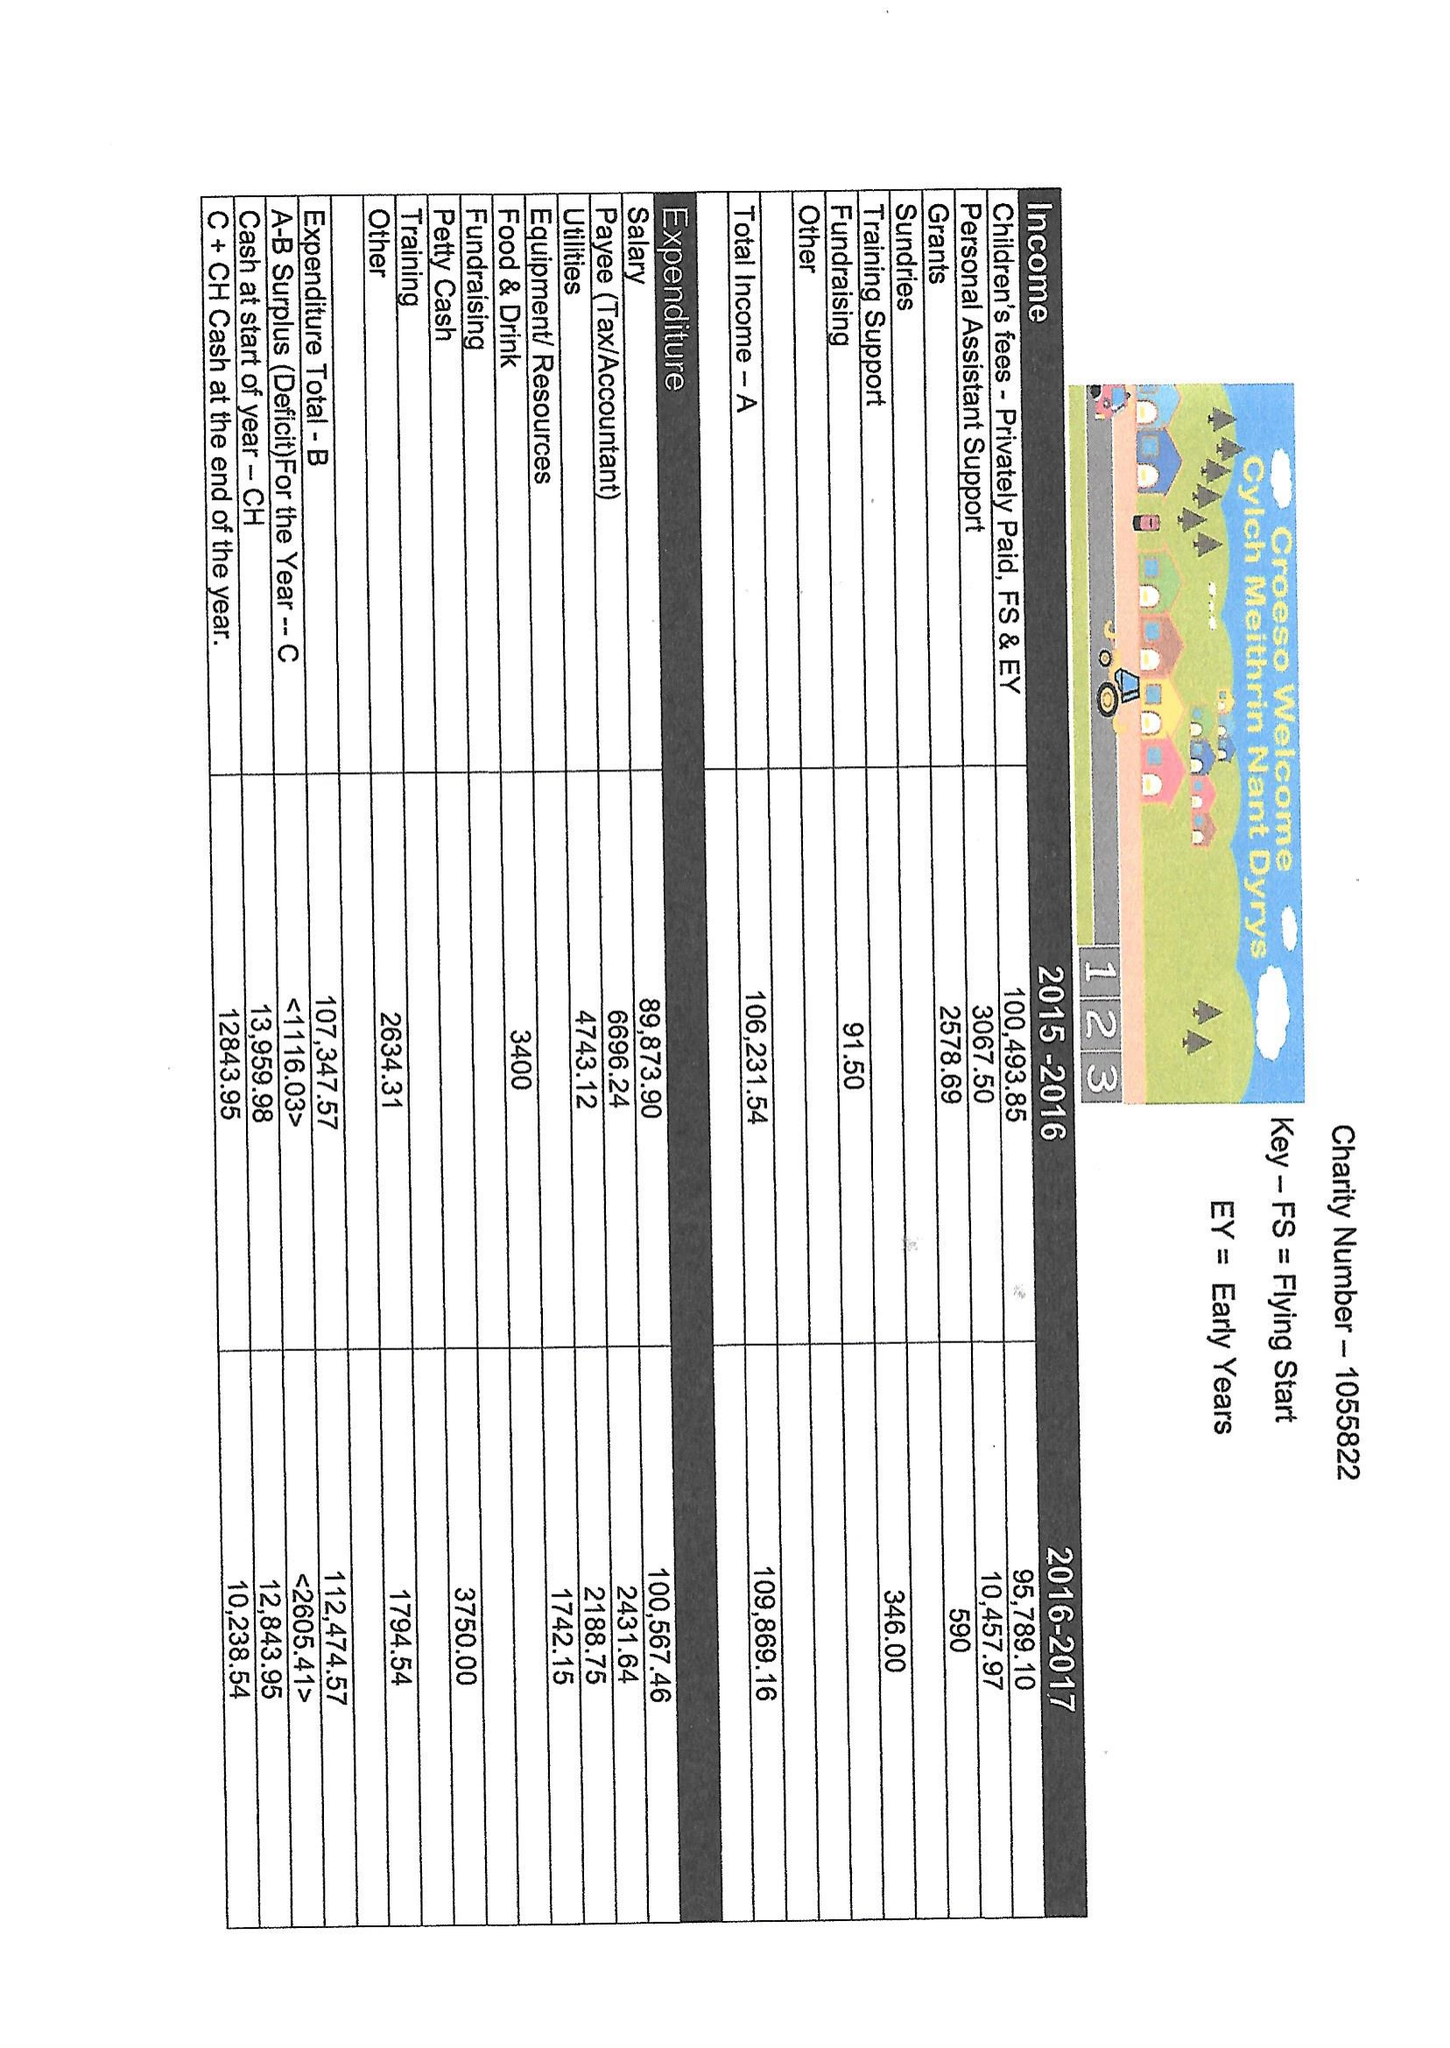What is the value for the report_date?
Answer the question using a single word or phrase. None 